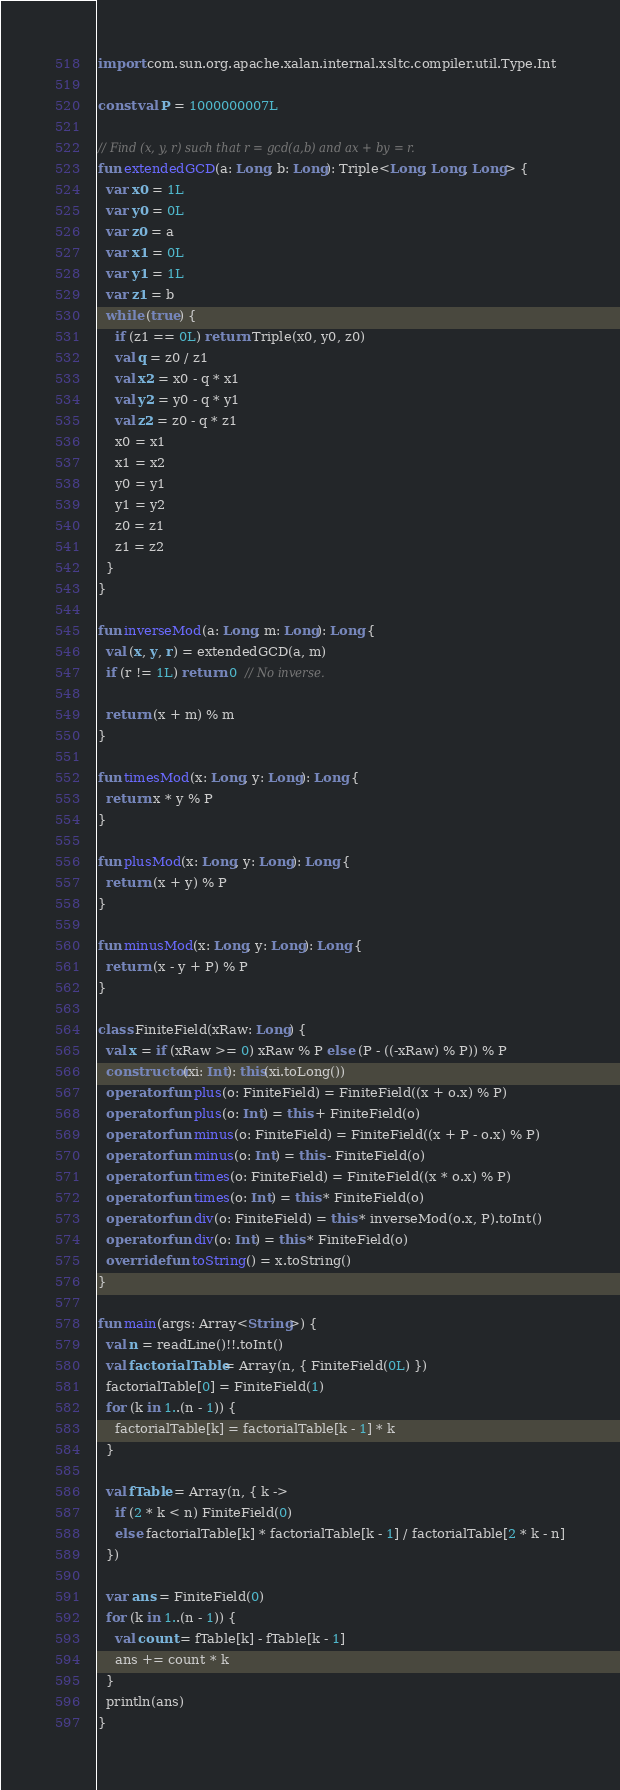Convert code to text. <code><loc_0><loc_0><loc_500><loc_500><_Kotlin_>
import com.sun.org.apache.xalan.internal.xsltc.compiler.util.Type.Int

const val P = 1000000007L

// Find (x, y, r) such that r = gcd(a,b) and ax + by = r.
fun extendedGCD(a: Long, b: Long): Triple<Long, Long, Long> {
  var x0 = 1L
  var y0 = 0L
  var z0 = a
  var x1 = 0L
  var y1 = 1L
  var z1 = b
  while (true) {
    if (z1 == 0L) return Triple(x0, y0, z0)
    val q = z0 / z1
    val x2 = x0 - q * x1
    val y2 = y0 - q * y1
    val z2 = z0 - q * z1
    x0 = x1
    x1 = x2
    y0 = y1
    y1 = y2
    z0 = z1
    z1 = z2
  }
}

fun inverseMod(a: Long, m: Long): Long {
  val (x, y, r) = extendedGCD(a, m)
  if (r != 1L) return 0  // No inverse.

  return (x + m) % m
}

fun timesMod(x: Long, y: Long): Long {
  return x * y % P
}

fun plusMod(x: Long, y: Long): Long {
  return (x + y) % P
}

fun minusMod(x: Long, y: Long): Long {
  return (x - y + P) % P
}

class FiniteField(xRaw: Long) {
  val x = if (xRaw >= 0) xRaw % P else (P - ((-xRaw) % P)) % P
  constructor(xi: Int): this(xi.toLong())
  operator fun plus(o: FiniteField) = FiniteField((x + o.x) % P)
  operator fun plus(o: Int) = this + FiniteField(o)
  operator fun minus(o: FiniteField) = FiniteField((x + P - o.x) % P)
  operator fun minus(o: Int) = this - FiniteField(o)
  operator fun times(o: FiniteField) = FiniteField((x * o.x) % P)
  operator fun times(o: Int) = this * FiniteField(o)
  operator fun div(o: FiniteField) = this * inverseMod(o.x, P).toInt()
  operator fun div(o: Int) = this * FiniteField(o)
  override fun toString() = x.toString()
}

fun main(args: Array<String>) {
  val n = readLine()!!.toInt()
  val factorialTable = Array(n, { FiniteField(0L) })
  factorialTable[0] = FiniteField(1)
  for (k in 1..(n - 1)) {
    factorialTable[k] = factorialTable[k - 1] * k
  }

  val fTable = Array(n, { k ->
    if (2 * k < n) FiniteField(0)
    else factorialTable[k] * factorialTable[k - 1] / factorialTable[2 * k - n]
  })

  var ans = FiniteField(0)
  for (k in 1..(n - 1)) {
    val count = fTable[k] - fTable[k - 1]
    ans += count * k
  }
  println(ans)
}</code> 